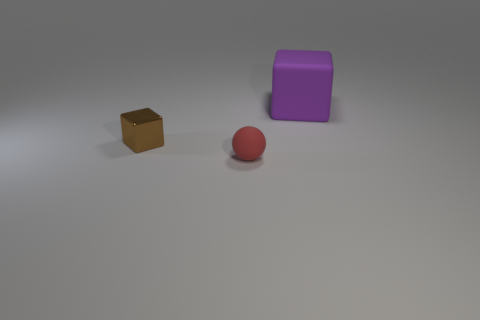Add 1 purple things. How many objects exist? 4 Add 2 red rubber spheres. How many red rubber spheres exist? 3 Subtract 0 yellow cylinders. How many objects are left? 3 Subtract all balls. How many objects are left? 2 Subtract all tiny brown cubes. Subtract all purple things. How many objects are left? 1 Add 1 brown metal blocks. How many brown metal blocks are left? 2 